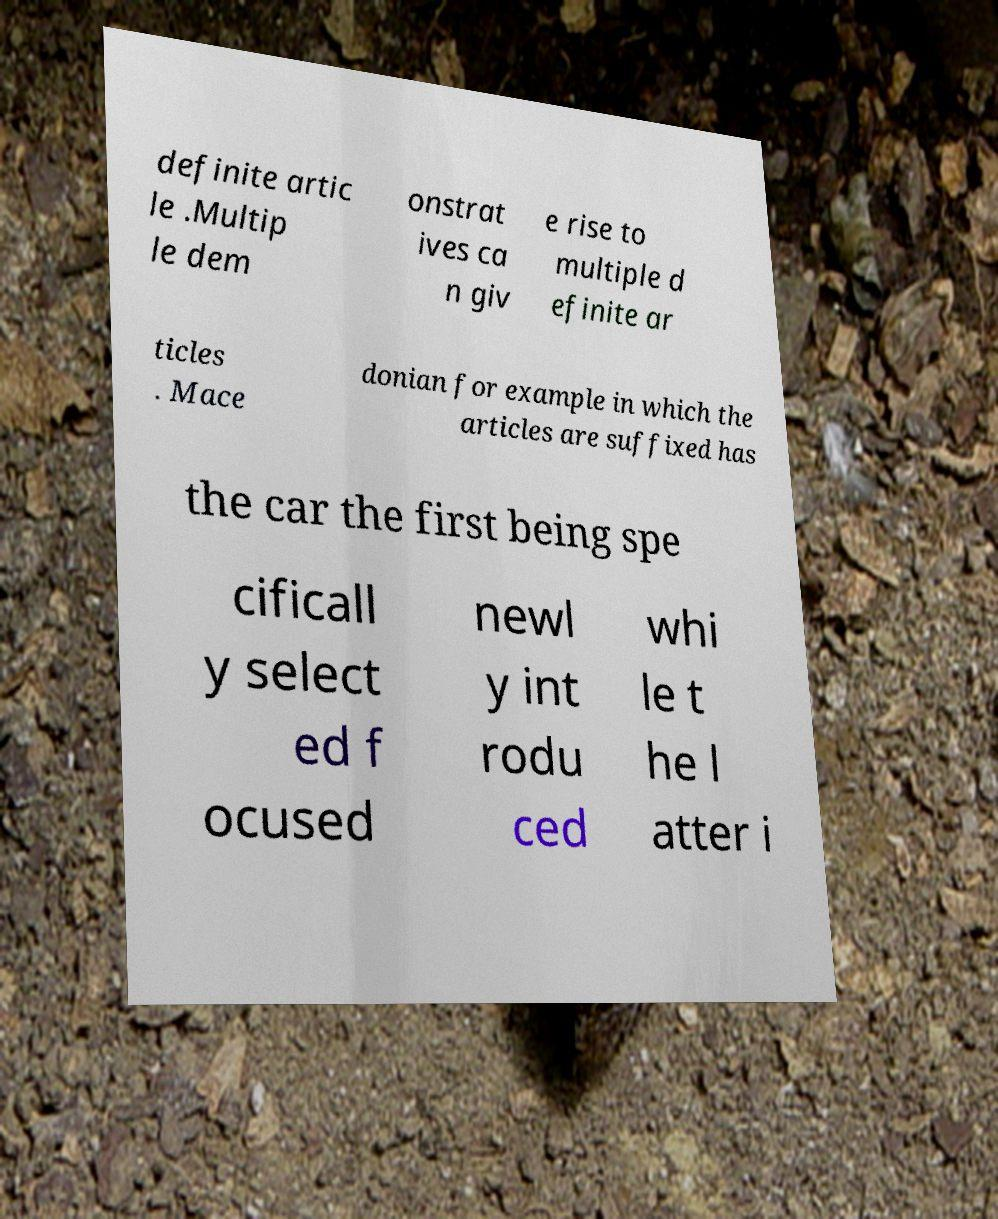Please read and relay the text visible in this image. What does it say? definite artic le .Multip le dem onstrat ives ca n giv e rise to multiple d efinite ar ticles . Mace donian for example in which the articles are suffixed has the car the first being spe cificall y select ed f ocused newl y int rodu ced whi le t he l atter i 